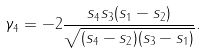Convert formula to latex. <formula><loc_0><loc_0><loc_500><loc_500>\gamma _ { 4 } = - 2 \frac { s _ { 4 } s _ { 3 } ( s _ { 1 } - s _ { 2 } ) } { \sqrt { ( s _ { 4 } - s _ { 2 } ) ( s _ { 3 } - s _ { 1 } ) } } .</formula> 